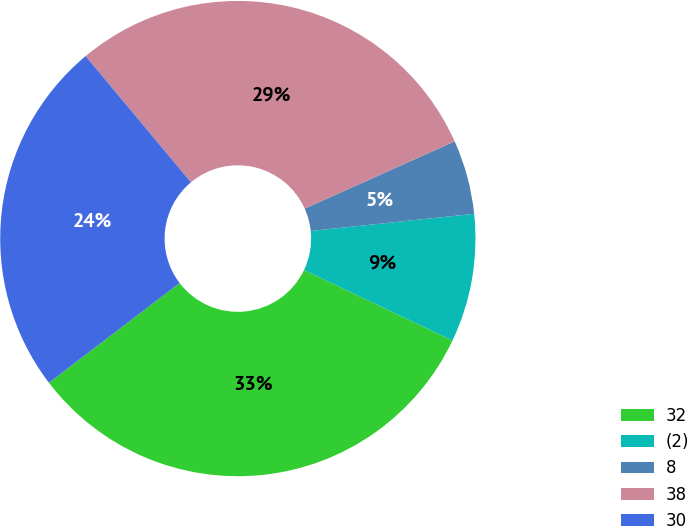Convert chart to OTSL. <chart><loc_0><loc_0><loc_500><loc_500><pie_chart><fcel>32<fcel>(2)<fcel>8<fcel>38<fcel>30<nl><fcel>32.57%<fcel>8.72%<fcel>5.05%<fcel>29.36%<fcel>24.31%<nl></chart> 